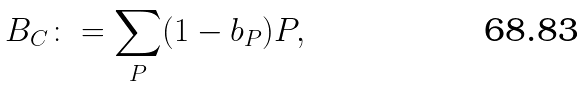<formula> <loc_0><loc_0><loc_500><loc_500>B _ { C } \colon = \sum _ { P } ( 1 - b _ { P } ) P ,</formula> 